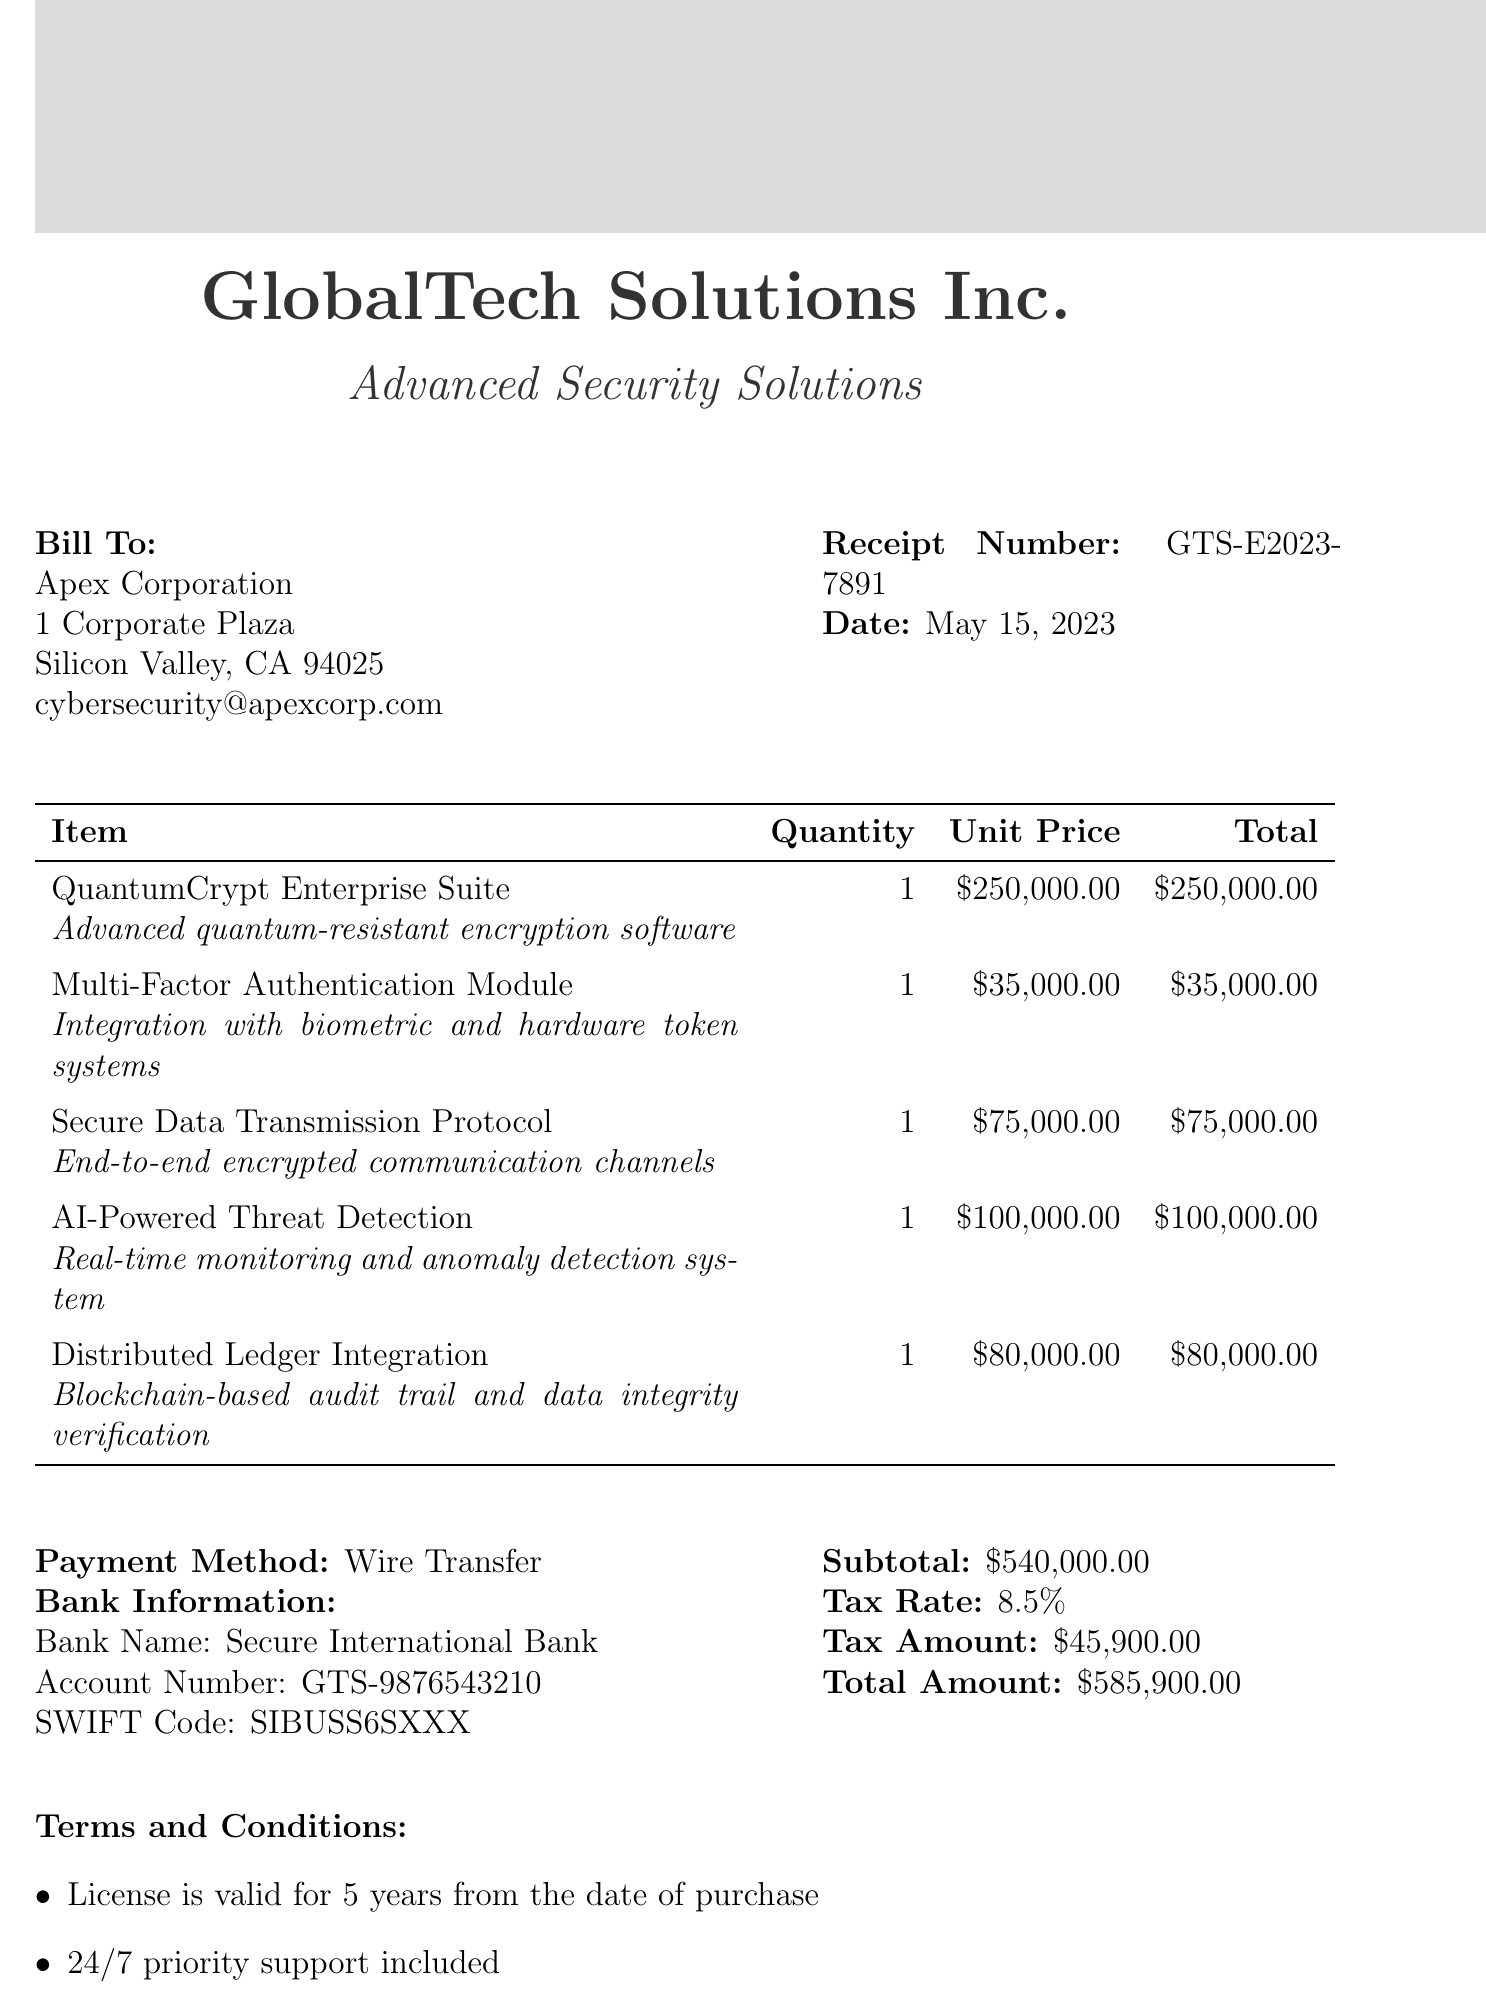What is the receipt number? The receipt number is a specific identifier for the transaction provided in the document.
Answer: GTS-E2023-7891 What is the date of purchase? The date of purchase is presented as the transaction date in the document.
Answer: May 15, 2023 What is the total amount due? The total amount is the aggregate sum of all transactions including tax, presented at the end of the document.
Answer: $585,900.00 Which module integrates with biometric systems? The module that integrates with biometric systems is specified in the list of items, outlining its specific function.
Answer: Multi-Factor Authentication Module What is the tax rate applied? The tax rate is mentioned in the financial section of the document, specifying the percentage used to calculate tax.
Answer: 8.5% What included feature provides priority support? The document states the included feature that offers priority assistance for clients, detailing support structure.
Answer: 24/7 priority support How long is the license valid? The validity period of the software license is outlined clearly in the terms and conditions section of the document.
Answer: 5 years What does the footer note refer to? The footer note provides a legal disclaimer regarding compliance with export control regulations associated with the purchase.
Answer: Export control regulations What payment method was used? The payment method is specified in the financial details section, which outlines how the transaction was settled.
Answer: Wire Transfer 